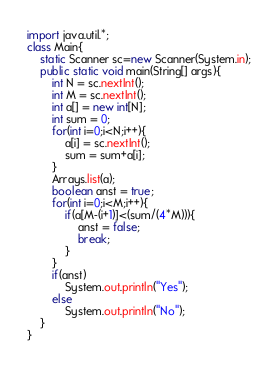Convert code to text. <code><loc_0><loc_0><loc_500><loc_500><_Java_>import java.util.*;
class Main{
    static Scanner sc=new Scanner(System.in);
    public static void main(String[] args){
        int N = sc.nextInt();
        int M = sc.nextInt();
        int a[] = new int[N];
        int sum = 0;
        for(int i=0;i<N;i++){
            a[i] = sc.nextInt();
            sum = sum+a[i];
        }
        Arrays.list(a);
        boolean anst = true;
        for(int i=0;i<M;i++){
            if(a[M-(i+1)]<(sum/(4*M))){
                anst = false;
                break;
            }
        }
        if(anst)
            System.out.println("Yes");
        else
            System.out.println("No");
    }
}</code> 